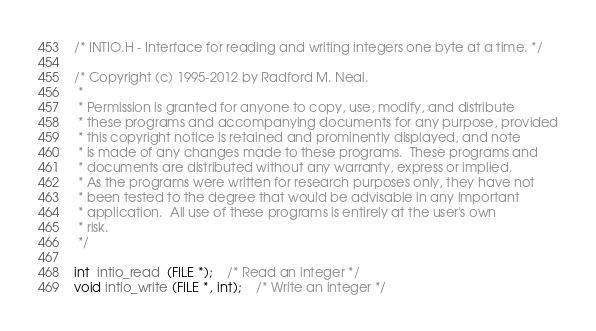<code> <loc_0><loc_0><loc_500><loc_500><_C_>/* INTIO.H - Interface for reading and writing integers one byte at a time. */

/* Copyright (c) 1995-2012 by Radford M. Neal.
 *
 * Permission is granted for anyone to copy, use, modify, and distribute
 * these programs and accompanying documents for any purpose, provided
 * this copyright notice is retained and prominently displayed, and note
 * is made of any changes made to these programs.  These programs and
 * documents are distributed without any warranty, express or implied.
 * As the programs were written for research purposes only, they have not
 * been tested to the degree that would be advisable in any important
 * application.  All use of these programs is entirely at the user's own
 * risk.
 */

int  intio_read  (FILE *);	/* Read an integer */
void intio_write (FILE *, int);	/* Write an integer */
</code> 